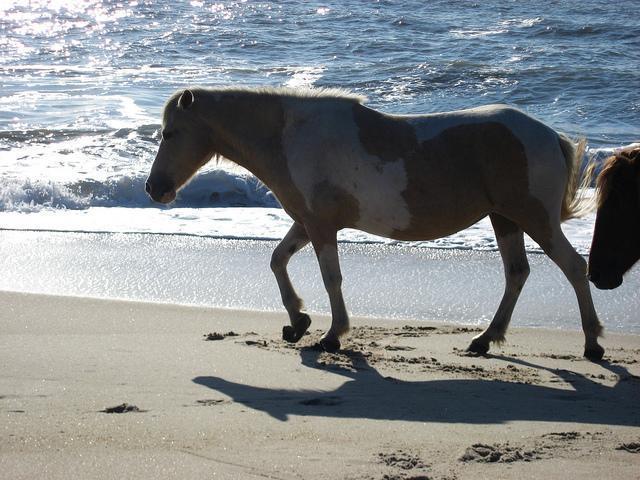How many horses are there?
Give a very brief answer. 2. 